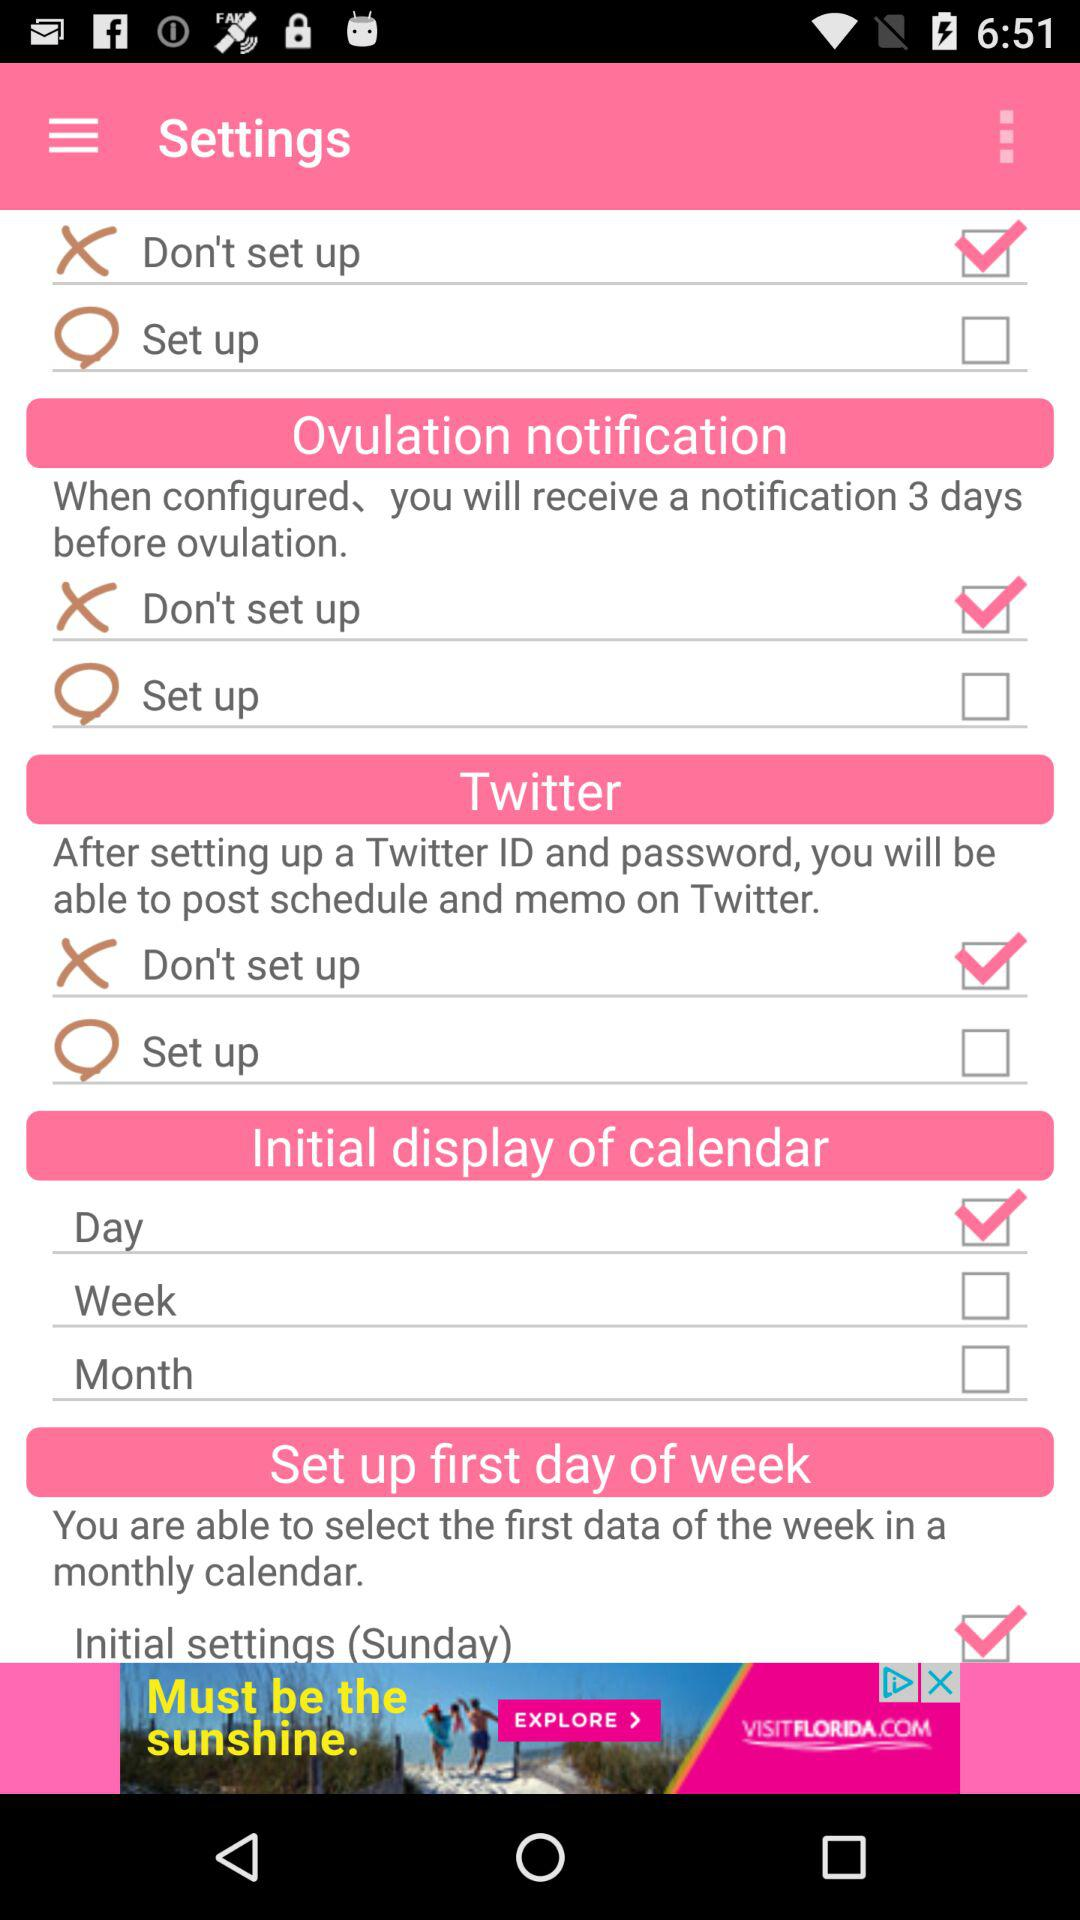What is the status of Don't set up?
When the provided information is insufficient, respond with <no answer>. <no answer> 